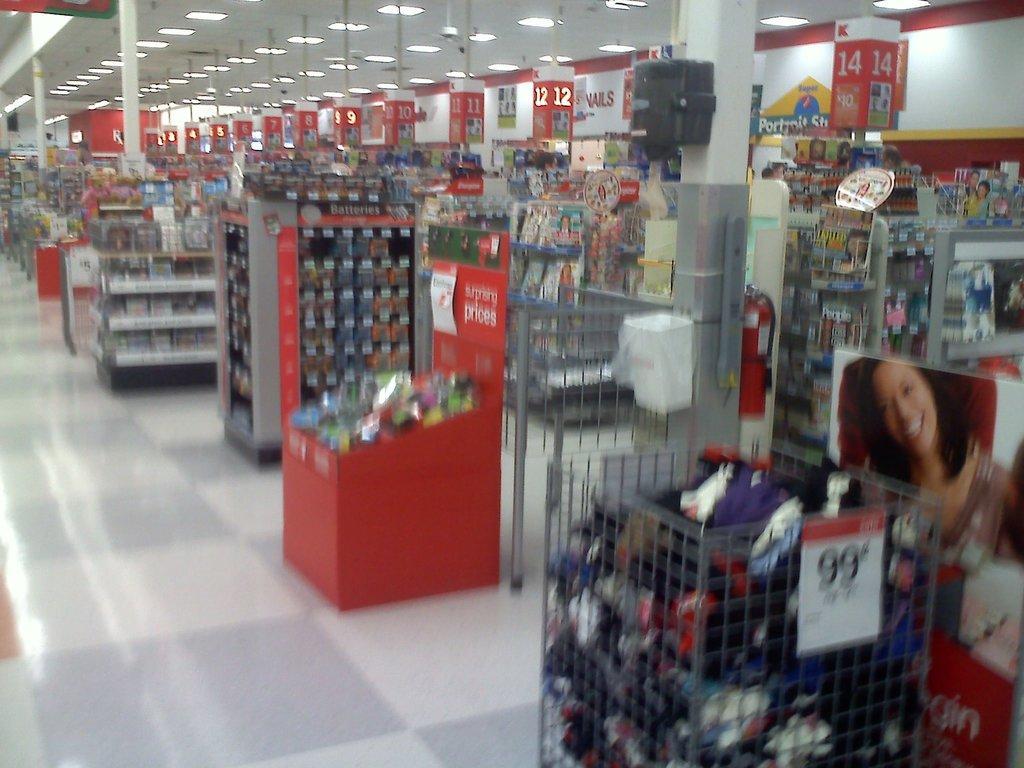Could you give a brief overview of what you see in this image? This is a picture taken in a supermarket. In this picture there are cupboards, posters, numbers, lights, name boards and many other objects. In the foreground it is well. 